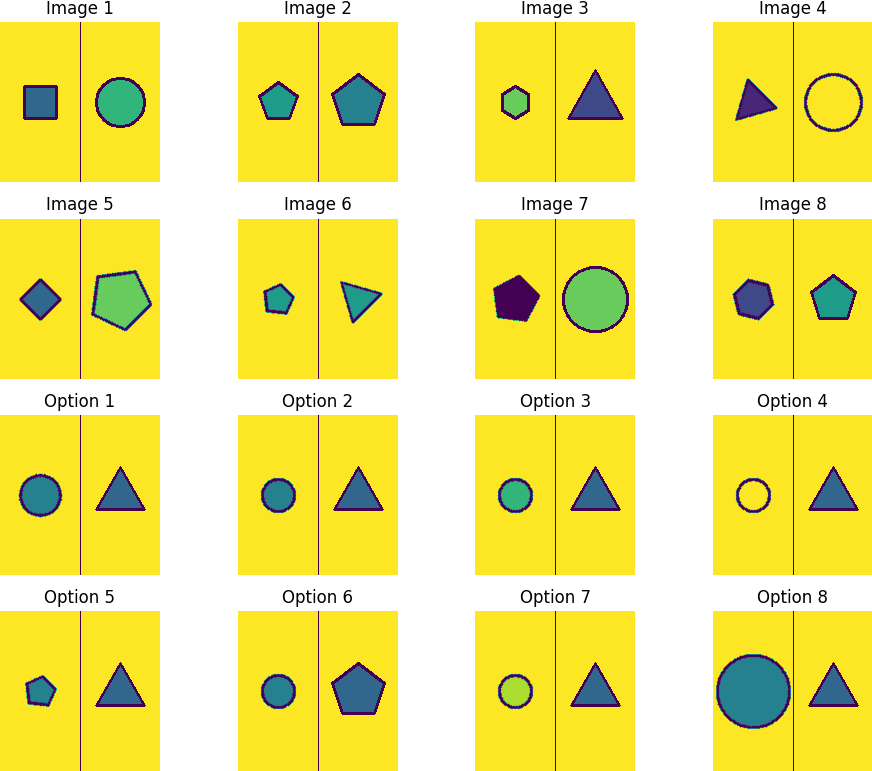Could there be a mathematical pattern or formula associated with the arrangement of colors? Indeed, examining the color arrangement, one could theorize the presence of a mathematical pattern or cycle in the sequence. The colors change predictably every image, cycling between three hues. This can be related to modular arithmetic, where the color index could be considered modulo 3. This provides a formulaic approach that could apply in coding sequences or creating algorithms for visual patterns. 